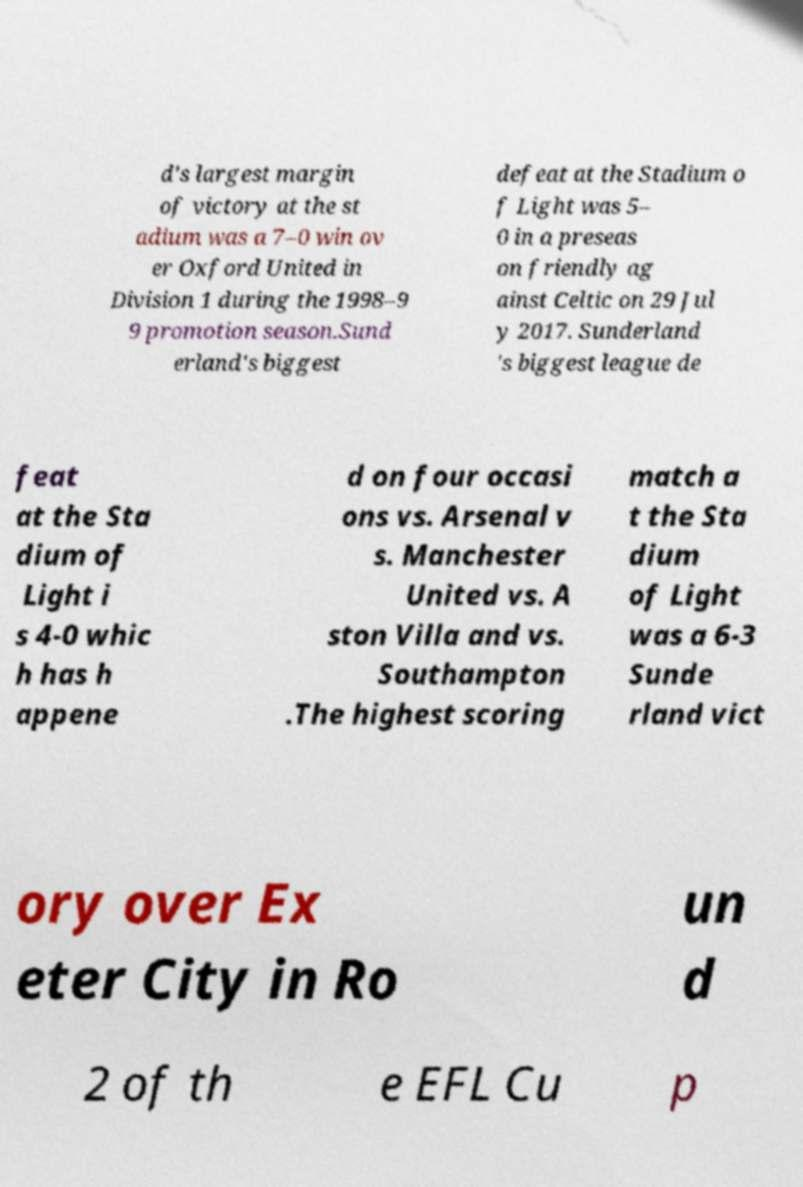What messages or text are displayed in this image? I need them in a readable, typed format. d's largest margin of victory at the st adium was a 7–0 win ov er Oxford United in Division 1 during the 1998–9 9 promotion season.Sund erland's biggest defeat at the Stadium o f Light was 5– 0 in a preseas on friendly ag ainst Celtic on 29 Jul y 2017. Sunderland 's biggest league de feat at the Sta dium of Light i s 4-0 whic h has h appene d on four occasi ons vs. Arsenal v s. Manchester United vs. A ston Villa and vs. Southampton .The highest scoring match a t the Sta dium of Light was a 6-3 Sunde rland vict ory over Ex eter City in Ro un d 2 of th e EFL Cu p 